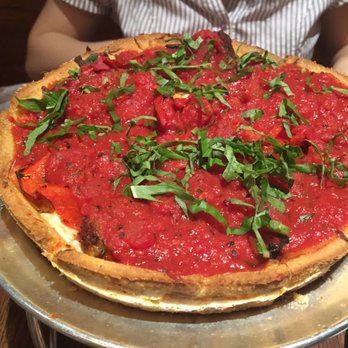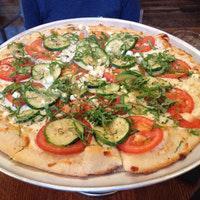The first image is the image on the left, the second image is the image on the right. Examine the images to the left and right. Is the description "Both pizzas are cut into slices." accurate? Answer yes or no. Yes. The first image is the image on the left, the second image is the image on the right. Considering the images on both sides, is "Neither pizza is in a pan with sides, one is a New York style thin pizza, the other is a Chicago style deep dish." valid? Answer yes or no. Yes. 